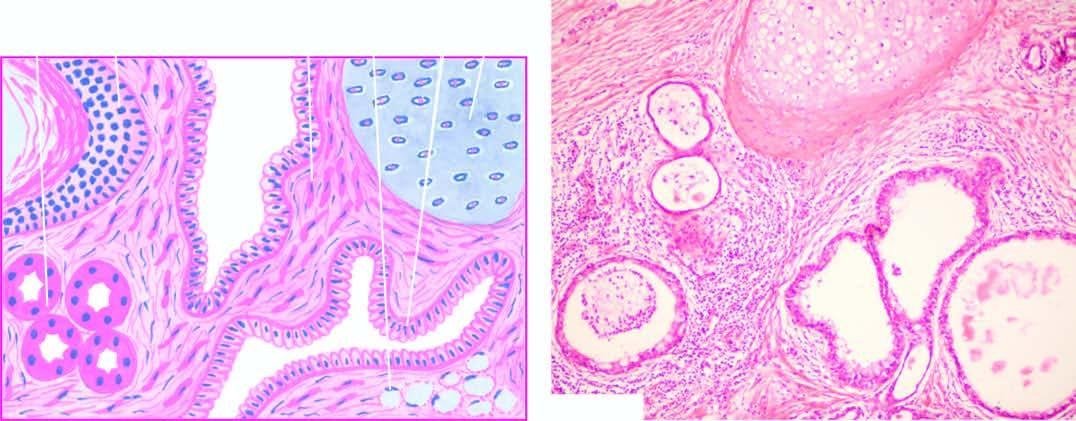croscopy shows characteristic lining of the cyst wall by epidermis and whose appendages?
Answer the question using a single word or phrase. Its 